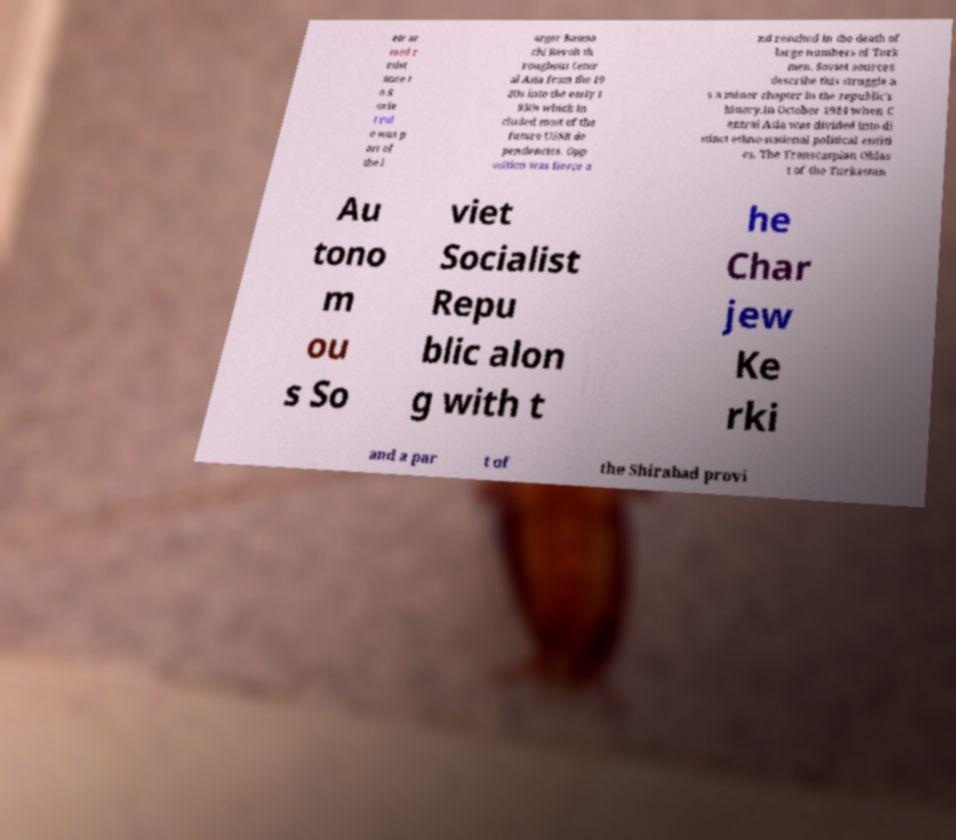Could you assist in decoding the text presented in this image and type it out clearly? eir ar med r esist ance t o S ovie t rul e was p art of the l arger Basma chi Revolt th roughout Centr al Asia from the 19 20s into the early 1 930s which in cluded most of the future USSR de pendencies. Opp osition was fierce a nd resulted in the death of large numbers of Turk men. Soviet sources describe this struggle a s a minor chapter in the republic's history.In October 1924 when C entral Asia was divided into di stinct ethno-national political entiti es. The Transcaspian Oblas t of the Turkestan Au tono m ou s So viet Socialist Repu blic alon g with t he Char jew Ke rki and a par t of the Shirabad provi 